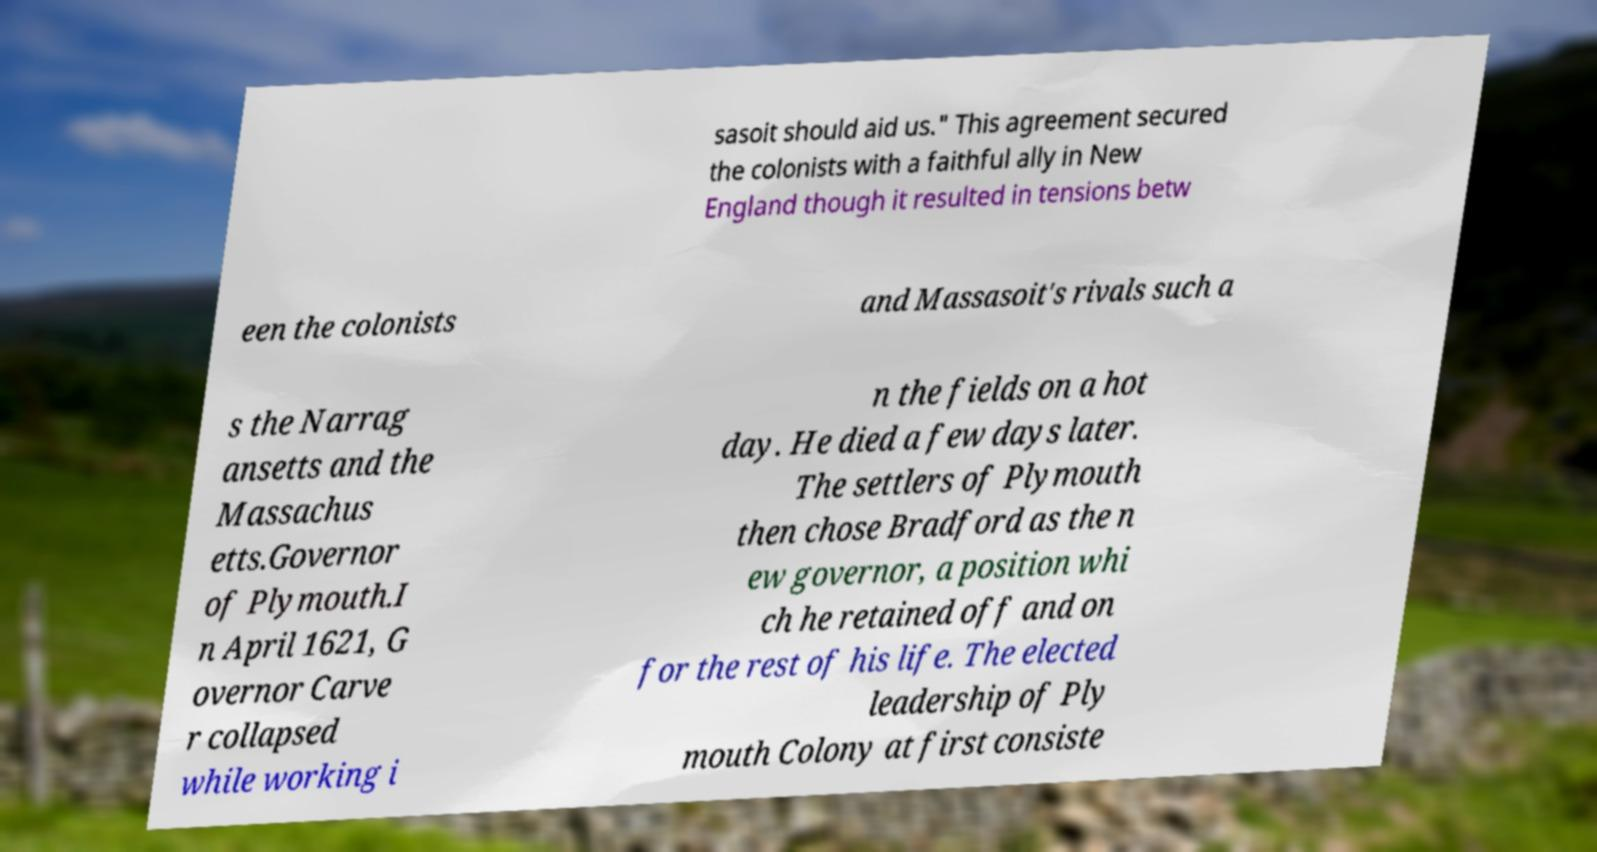There's text embedded in this image that I need extracted. Can you transcribe it verbatim? sasoit should aid us." This agreement secured the colonists with a faithful ally in New England though it resulted in tensions betw een the colonists and Massasoit's rivals such a s the Narrag ansetts and the Massachus etts.Governor of Plymouth.I n April 1621, G overnor Carve r collapsed while working i n the fields on a hot day. He died a few days later. The settlers of Plymouth then chose Bradford as the n ew governor, a position whi ch he retained off and on for the rest of his life. The elected leadership of Ply mouth Colony at first consiste 